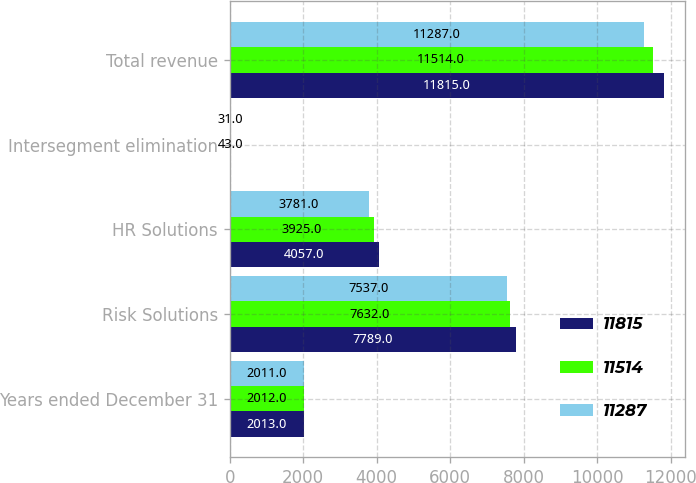Convert chart. <chart><loc_0><loc_0><loc_500><loc_500><stacked_bar_chart><ecel><fcel>Years ended December 31<fcel>Risk Solutions<fcel>HR Solutions<fcel>Intersegment elimination<fcel>Total revenue<nl><fcel>11815<fcel>2013<fcel>7789<fcel>4057<fcel>31<fcel>11815<nl><fcel>11514<fcel>2012<fcel>7632<fcel>3925<fcel>43<fcel>11514<nl><fcel>11287<fcel>2011<fcel>7537<fcel>3781<fcel>31<fcel>11287<nl></chart> 